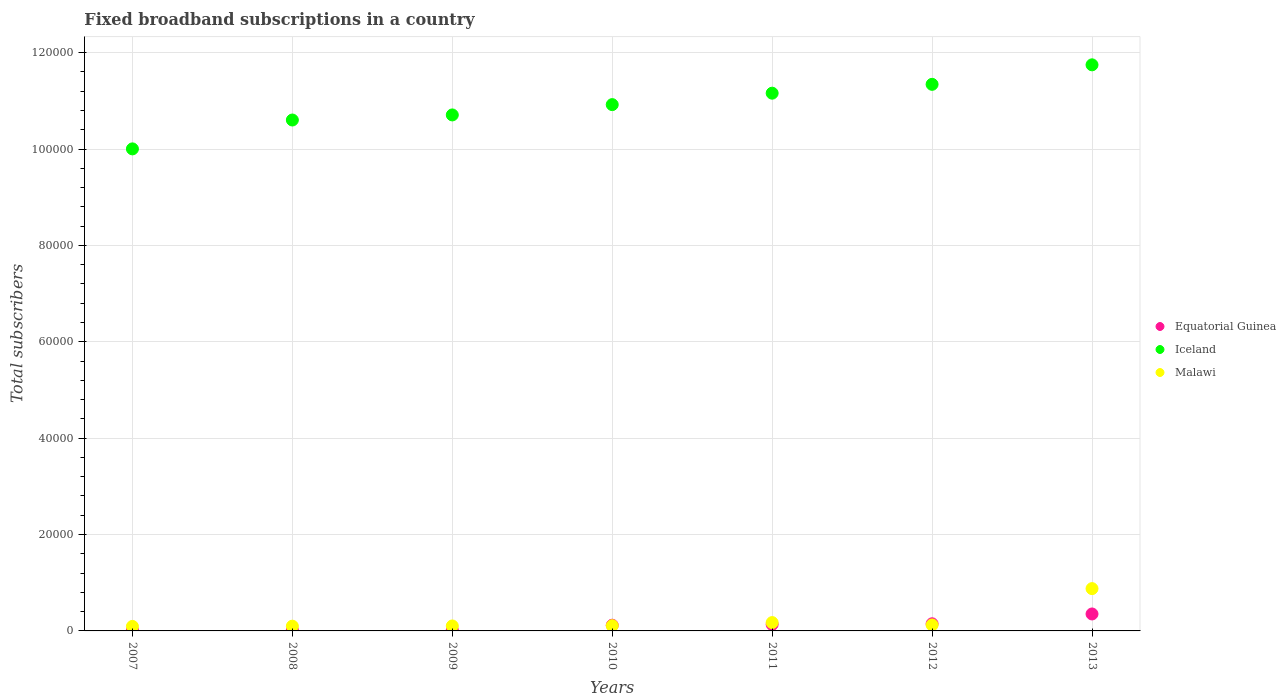What is the number of broadband subscriptions in Iceland in 2012?
Make the answer very short. 1.13e+05. Across all years, what is the maximum number of broadband subscriptions in Equatorial Guinea?
Your answer should be very brief. 3518. Across all years, what is the minimum number of broadband subscriptions in Iceland?
Offer a very short reply. 1.00e+05. What is the total number of broadband subscriptions in Iceland in the graph?
Make the answer very short. 7.65e+05. What is the difference between the number of broadband subscriptions in Iceland in 2007 and that in 2012?
Keep it short and to the point. -1.34e+04. What is the difference between the number of broadband subscriptions in Iceland in 2008 and the number of broadband subscriptions in Equatorial Guinea in 2007?
Keep it short and to the point. 1.06e+05. What is the average number of broadband subscriptions in Iceland per year?
Ensure brevity in your answer.  1.09e+05. In the year 2009, what is the difference between the number of broadband subscriptions in Malawi and number of broadband subscriptions in Equatorial Guinea?
Ensure brevity in your answer.  854. What is the ratio of the number of broadband subscriptions in Malawi in 2008 to that in 2010?
Make the answer very short. 0.91. Is the number of broadband subscriptions in Malawi in 2010 less than that in 2012?
Your answer should be very brief. Yes. What is the difference between the highest and the second highest number of broadband subscriptions in Malawi?
Provide a short and direct response. 7047. What is the difference between the highest and the lowest number of broadband subscriptions in Equatorial Guinea?
Make the answer very short. 3338. Is the sum of the number of broadband subscriptions in Equatorial Guinea in 2008 and 2010 greater than the maximum number of broadband subscriptions in Iceland across all years?
Make the answer very short. No. Is it the case that in every year, the sum of the number of broadband subscriptions in Iceland and number of broadband subscriptions in Malawi  is greater than the number of broadband subscriptions in Equatorial Guinea?
Make the answer very short. Yes. Is the number of broadband subscriptions in Equatorial Guinea strictly greater than the number of broadband subscriptions in Iceland over the years?
Offer a very short reply. No. How many dotlines are there?
Your answer should be compact. 3. How many years are there in the graph?
Your answer should be very brief. 7. Where does the legend appear in the graph?
Make the answer very short. Center right. How many legend labels are there?
Offer a very short reply. 3. How are the legend labels stacked?
Your answer should be very brief. Vertical. What is the title of the graph?
Provide a succinct answer. Fixed broadband subscriptions in a country. What is the label or title of the Y-axis?
Provide a short and direct response. Total subscribers. What is the Total subscribers of Equatorial Guinea in 2007?
Ensure brevity in your answer.  180. What is the Total subscribers in Iceland in 2007?
Provide a short and direct response. 1.00e+05. What is the Total subscribers in Malawi in 2007?
Make the answer very short. 934. What is the Total subscribers of Equatorial Guinea in 2008?
Give a very brief answer. 180. What is the Total subscribers in Iceland in 2008?
Your answer should be compact. 1.06e+05. What is the Total subscribers in Malawi in 2008?
Make the answer very short. 986. What is the Total subscribers in Equatorial Guinea in 2009?
Make the answer very short. 180. What is the Total subscribers of Iceland in 2009?
Keep it short and to the point. 1.07e+05. What is the Total subscribers in Malawi in 2009?
Give a very brief answer. 1034. What is the Total subscribers in Equatorial Guinea in 2010?
Offer a very short reply. 1186. What is the Total subscribers of Iceland in 2010?
Your answer should be very brief. 1.09e+05. What is the Total subscribers of Malawi in 2010?
Ensure brevity in your answer.  1085. What is the Total subscribers of Equatorial Guinea in 2011?
Your answer should be compact. 1346. What is the Total subscribers in Iceland in 2011?
Your answer should be compact. 1.12e+05. What is the Total subscribers in Malawi in 2011?
Your response must be concise. 1730. What is the Total subscribers in Equatorial Guinea in 2012?
Your answer should be compact. 1480. What is the Total subscribers of Iceland in 2012?
Provide a succinct answer. 1.13e+05. What is the Total subscribers in Malawi in 2012?
Provide a short and direct response. 1238. What is the Total subscribers of Equatorial Guinea in 2013?
Your answer should be compact. 3518. What is the Total subscribers of Iceland in 2013?
Ensure brevity in your answer.  1.17e+05. What is the Total subscribers in Malawi in 2013?
Provide a short and direct response. 8777. Across all years, what is the maximum Total subscribers of Equatorial Guinea?
Your answer should be compact. 3518. Across all years, what is the maximum Total subscribers in Iceland?
Offer a very short reply. 1.17e+05. Across all years, what is the maximum Total subscribers of Malawi?
Provide a succinct answer. 8777. Across all years, what is the minimum Total subscribers in Equatorial Guinea?
Keep it short and to the point. 180. Across all years, what is the minimum Total subscribers of Iceland?
Keep it short and to the point. 1.00e+05. Across all years, what is the minimum Total subscribers in Malawi?
Provide a short and direct response. 934. What is the total Total subscribers of Equatorial Guinea in the graph?
Make the answer very short. 8070. What is the total Total subscribers of Iceland in the graph?
Provide a short and direct response. 7.65e+05. What is the total Total subscribers in Malawi in the graph?
Your answer should be very brief. 1.58e+04. What is the difference between the Total subscribers of Equatorial Guinea in 2007 and that in 2008?
Make the answer very short. 0. What is the difference between the Total subscribers in Iceland in 2007 and that in 2008?
Provide a short and direct response. -5991. What is the difference between the Total subscribers in Malawi in 2007 and that in 2008?
Provide a short and direct response. -52. What is the difference between the Total subscribers in Iceland in 2007 and that in 2009?
Your answer should be very brief. -7046. What is the difference between the Total subscribers of Malawi in 2007 and that in 2009?
Ensure brevity in your answer.  -100. What is the difference between the Total subscribers of Equatorial Guinea in 2007 and that in 2010?
Your answer should be very brief. -1006. What is the difference between the Total subscribers of Iceland in 2007 and that in 2010?
Provide a succinct answer. -9186. What is the difference between the Total subscribers of Malawi in 2007 and that in 2010?
Offer a very short reply. -151. What is the difference between the Total subscribers in Equatorial Guinea in 2007 and that in 2011?
Make the answer very short. -1166. What is the difference between the Total subscribers in Iceland in 2007 and that in 2011?
Your response must be concise. -1.16e+04. What is the difference between the Total subscribers of Malawi in 2007 and that in 2011?
Make the answer very short. -796. What is the difference between the Total subscribers of Equatorial Guinea in 2007 and that in 2012?
Your answer should be compact. -1300. What is the difference between the Total subscribers of Iceland in 2007 and that in 2012?
Provide a short and direct response. -1.34e+04. What is the difference between the Total subscribers of Malawi in 2007 and that in 2012?
Offer a very short reply. -304. What is the difference between the Total subscribers of Equatorial Guinea in 2007 and that in 2013?
Keep it short and to the point. -3338. What is the difference between the Total subscribers of Iceland in 2007 and that in 2013?
Your answer should be very brief. -1.74e+04. What is the difference between the Total subscribers of Malawi in 2007 and that in 2013?
Offer a very short reply. -7843. What is the difference between the Total subscribers of Equatorial Guinea in 2008 and that in 2009?
Make the answer very short. 0. What is the difference between the Total subscribers in Iceland in 2008 and that in 2009?
Make the answer very short. -1055. What is the difference between the Total subscribers in Malawi in 2008 and that in 2009?
Provide a succinct answer. -48. What is the difference between the Total subscribers in Equatorial Guinea in 2008 and that in 2010?
Keep it short and to the point. -1006. What is the difference between the Total subscribers in Iceland in 2008 and that in 2010?
Offer a terse response. -3195. What is the difference between the Total subscribers in Malawi in 2008 and that in 2010?
Your answer should be very brief. -99. What is the difference between the Total subscribers in Equatorial Guinea in 2008 and that in 2011?
Keep it short and to the point. -1166. What is the difference between the Total subscribers of Iceland in 2008 and that in 2011?
Give a very brief answer. -5567. What is the difference between the Total subscribers of Malawi in 2008 and that in 2011?
Offer a terse response. -744. What is the difference between the Total subscribers of Equatorial Guinea in 2008 and that in 2012?
Your response must be concise. -1300. What is the difference between the Total subscribers in Iceland in 2008 and that in 2012?
Ensure brevity in your answer.  -7403. What is the difference between the Total subscribers of Malawi in 2008 and that in 2012?
Your answer should be compact. -252. What is the difference between the Total subscribers in Equatorial Guinea in 2008 and that in 2013?
Provide a short and direct response. -3338. What is the difference between the Total subscribers of Iceland in 2008 and that in 2013?
Your answer should be compact. -1.14e+04. What is the difference between the Total subscribers in Malawi in 2008 and that in 2013?
Your answer should be very brief. -7791. What is the difference between the Total subscribers of Equatorial Guinea in 2009 and that in 2010?
Offer a terse response. -1006. What is the difference between the Total subscribers in Iceland in 2009 and that in 2010?
Ensure brevity in your answer.  -2140. What is the difference between the Total subscribers of Malawi in 2009 and that in 2010?
Provide a short and direct response. -51. What is the difference between the Total subscribers of Equatorial Guinea in 2009 and that in 2011?
Your answer should be very brief. -1166. What is the difference between the Total subscribers of Iceland in 2009 and that in 2011?
Make the answer very short. -4512. What is the difference between the Total subscribers in Malawi in 2009 and that in 2011?
Provide a short and direct response. -696. What is the difference between the Total subscribers of Equatorial Guinea in 2009 and that in 2012?
Provide a succinct answer. -1300. What is the difference between the Total subscribers in Iceland in 2009 and that in 2012?
Give a very brief answer. -6348. What is the difference between the Total subscribers in Malawi in 2009 and that in 2012?
Offer a very short reply. -204. What is the difference between the Total subscribers in Equatorial Guinea in 2009 and that in 2013?
Make the answer very short. -3338. What is the difference between the Total subscribers of Iceland in 2009 and that in 2013?
Your answer should be very brief. -1.04e+04. What is the difference between the Total subscribers of Malawi in 2009 and that in 2013?
Offer a very short reply. -7743. What is the difference between the Total subscribers of Equatorial Guinea in 2010 and that in 2011?
Keep it short and to the point. -160. What is the difference between the Total subscribers in Iceland in 2010 and that in 2011?
Your answer should be compact. -2372. What is the difference between the Total subscribers in Malawi in 2010 and that in 2011?
Offer a terse response. -645. What is the difference between the Total subscribers of Equatorial Guinea in 2010 and that in 2012?
Ensure brevity in your answer.  -294. What is the difference between the Total subscribers of Iceland in 2010 and that in 2012?
Offer a very short reply. -4208. What is the difference between the Total subscribers in Malawi in 2010 and that in 2012?
Your response must be concise. -153. What is the difference between the Total subscribers in Equatorial Guinea in 2010 and that in 2013?
Your response must be concise. -2332. What is the difference between the Total subscribers of Iceland in 2010 and that in 2013?
Offer a very short reply. -8255. What is the difference between the Total subscribers of Malawi in 2010 and that in 2013?
Your answer should be compact. -7692. What is the difference between the Total subscribers in Equatorial Guinea in 2011 and that in 2012?
Your answer should be very brief. -134. What is the difference between the Total subscribers in Iceland in 2011 and that in 2012?
Keep it short and to the point. -1836. What is the difference between the Total subscribers in Malawi in 2011 and that in 2012?
Your response must be concise. 492. What is the difference between the Total subscribers of Equatorial Guinea in 2011 and that in 2013?
Make the answer very short. -2172. What is the difference between the Total subscribers in Iceland in 2011 and that in 2013?
Give a very brief answer. -5883. What is the difference between the Total subscribers in Malawi in 2011 and that in 2013?
Make the answer very short. -7047. What is the difference between the Total subscribers in Equatorial Guinea in 2012 and that in 2013?
Your answer should be compact. -2038. What is the difference between the Total subscribers of Iceland in 2012 and that in 2013?
Provide a succinct answer. -4047. What is the difference between the Total subscribers of Malawi in 2012 and that in 2013?
Your answer should be very brief. -7539. What is the difference between the Total subscribers in Equatorial Guinea in 2007 and the Total subscribers in Iceland in 2008?
Ensure brevity in your answer.  -1.06e+05. What is the difference between the Total subscribers in Equatorial Guinea in 2007 and the Total subscribers in Malawi in 2008?
Your response must be concise. -806. What is the difference between the Total subscribers of Iceland in 2007 and the Total subscribers of Malawi in 2008?
Your answer should be very brief. 9.90e+04. What is the difference between the Total subscribers in Equatorial Guinea in 2007 and the Total subscribers in Iceland in 2009?
Your answer should be compact. -1.07e+05. What is the difference between the Total subscribers in Equatorial Guinea in 2007 and the Total subscribers in Malawi in 2009?
Your answer should be very brief. -854. What is the difference between the Total subscribers in Iceland in 2007 and the Total subscribers in Malawi in 2009?
Provide a short and direct response. 9.90e+04. What is the difference between the Total subscribers in Equatorial Guinea in 2007 and the Total subscribers in Iceland in 2010?
Your response must be concise. -1.09e+05. What is the difference between the Total subscribers in Equatorial Guinea in 2007 and the Total subscribers in Malawi in 2010?
Give a very brief answer. -905. What is the difference between the Total subscribers in Iceland in 2007 and the Total subscribers in Malawi in 2010?
Provide a short and direct response. 9.89e+04. What is the difference between the Total subscribers in Equatorial Guinea in 2007 and the Total subscribers in Iceland in 2011?
Provide a succinct answer. -1.11e+05. What is the difference between the Total subscribers of Equatorial Guinea in 2007 and the Total subscribers of Malawi in 2011?
Ensure brevity in your answer.  -1550. What is the difference between the Total subscribers in Iceland in 2007 and the Total subscribers in Malawi in 2011?
Offer a very short reply. 9.83e+04. What is the difference between the Total subscribers of Equatorial Guinea in 2007 and the Total subscribers of Iceland in 2012?
Give a very brief answer. -1.13e+05. What is the difference between the Total subscribers of Equatorial Guinea in 2007 and the Total subscribers of Malawi in 2012?
Ensure brevity in your answer.  -1058. What is the difference between the Total subscribers in Iceland in 2007 and the Total subscribers in Malawi in 2012?
Provide a succinct answer. 9.88e+04. What is the difference between the Total subscribers in Equatorial Guinea in 2007 and the Total subscribers in Iceland in 2013?
Keep it short and to the point. -1.17e+05. What is the difference between the Total subscribers of Equatorial Guinea in 2007 and the Total subscribers of Malawi in 2013?
Your response must be concise. -8597. What is the difference between the Total subscribers of Iceland in 2007 and the Total subscribers of Malawi in 2013?
Offer a terse response. 9.12e+04. What is the difference between the Total subscribers of Equatorial Guinea in 2008 and the Total subscribers of Iceland in 2009?
Offer a terse response. -1.07e+05. What is the difference between the Total subscribers in Equatorial Guinea in 2008 and the Total subscribers in Malawi in 2009?
Provide a succinct answer. -854. What is the difference between the Total subscribers in Iceland in 2008 and the Total subscribers in Malawi in 2009?
Offer a terse response. 1.05e+05. What is the difference between the Total subscribers in Equatorial Guinea in 2008 and the Total subscribers in Iceland in 2010?
Offer a terse response. -1.09e+05. What is the difference between the Total subscribers in Equatorial Guinea in 2008 and the Total subscribers in Malawi in 2010?
Offer a terse response. -905. What is the difference between the Total subscribers in Iceland in 2008 and the Total subscribers in Malawi in 2010?
Your response must be concise. 1.05e+05. What is the difference between the Total subscribers in Equatorial Guinea in 2008 and the Total subscribers in Iceland in 2011?
Offer a terse response. -1.11e+05. What is the difference between the Total subscribers of Equatorial Guinea in 2008 and the Total subscribers of Malawi in 2011?
Provide a succinct answer. -1550. What is the difference between the Total subscribers in Iceland in 2008 and the Total subscribers in Malawi in 2011?
Ensure brevity in your answer.  1.04e+05. What is the difference between the Total subscribers in Equatorial Guinea in 2008 and the Total subscribers in Iceland in 2012?
Give a very brief answer. -1.13e+05. What is the difference between the Total subscribers of Equatorial Guinea in 2008 and the Total subscribers of Malawi in 2012?
Provide a short and direct response. -1058. What is the difference between the Total subscribers in Iceland in 2008 and the Total subscribers in Malawi in 2012?
Give a very brief answer. 1.05e+05. What is the difference between the Total subscribers in Equatorial Guinea in 2008 and the Total subscribers in Iceland in 2013?
Your response must be concise. -1.17e+05. What is the difference between the Total subscribers in Equatorial Guinea in 2008 and the Total subscribers in Malawi in 2013?
Your answer should be very brief. -8597. What is the difference between the Total subscribers in Iceland in 2008 and the Total subscribers in Malawi in 2013?
Give a very brief answer. 9.72e+04. What is the difference between the Total subscribers in Equatorial Guinea in 2009 and the Total subscribers in Iceland in 2010?
Give a very brief answer. -1.09e+05. What is the difference between the Total subscribers of Equatorial Guinea in 2009 and the Total subscribers of Malawi in 2010?
Keep it short and to the point. -905. What is the difference between the Total subscribers of Iceland in 2009 and the Total subscribers of Malawi in 2010?
Make the answer very short. 1.06e+05. What is the difference between the Total subscribers of Equatorial Guinea in 2009 and the Total subscribers of Iceland in 2011?
Give a very brief answer. -1.11e+05. What is the difference between the Total subscribers in Equatorial Guinea in 2009 and the Total subscribers in Malawi in 2011?
Offer a very short reply. -1550. What is the difference between the Total subscribers in Iceland in 2009 and the Total subscribers in Malawi in 2011?
Give a very brief answer. 1.05e+05. What is the difference between the Total subscribers in Equatorial Guinea in 2009 and the Total subscribers in Iceland in 2012?
Keep it short and to the point. -1.13e+05. What is the difference between the Total subscribers in Equatorial Guinea in 2009 and the Total subscribers in Malawi in 2012?
Give a very brief answer. -1058. What is the difference between the Total subscribers in Iceland in 2009 and the Total subscribers in Malawi in 2012?
Offer a terse response. 1.06e+05. What is the difference between the Total subscribers of Equatorial Guinea in 2009 and the Total subscribers of Iceland in 2013?
Your response must be concise. -1.17e+05. What is the difference between the Total subscribers in Equatorial Guinea in 2009 and the Total subscribers in Malawi in 2013?
Your response must be concise. -8597. What is the difference between the Total subscribers in Iceland in 2009 and the Total subscribers in Malawi in 2013?
Provide a short and direct response. 9.83e+04. What is the difference between the Total subscribers of Equatorial Guinea in 2010 and the Total subscribers of Iceland in 2011?
Provide a succinct answer. -1.10e+05. What is the difference between the Total subscribers of Equatorial Guinea in 2010 and the Total subscribers of Malawi in 2011?
Ensure brevity in your answer.  -544. What is the difference between the Total subscribers of Iceland in 2010 and the Total subscribers of Malawi in 2011?
Offer a terse response. 1.07e+05. What is the difference between the Total subscribers in Equatorial Guinea in 2010 and the Total subscribers in Iceland in 2012?
Your answer should be compact. -1.12e+05. What is the difference between the Total subscribers of Equatorial Guinea in 2010 and the Total subscribers of Malawi in 2012?
Offer a very short reply. -52. What is the difference between the Total subscribers of Iceland in 2010 and the Total subscribers of Malawi in 2012?
Offer a very short reply. 1.08e+05. What is the difference between the Total subscribers in Equatorial Guinea in 2010 and the Total subscribers in Iceland in 2013?
Your response must be concise. -1.16e+05. What is the difference between the Total subscribers of Equatorial Guinea in 2010 and the Total subscribers of Malawi in 2013?
Your answer should be compact. -7591. What is the difference between the Total subscribers in Iceland in 2010 and the Total subscribers in Malawi in 2013?
Provide a short and direct response. 1.00e+05. What is the difference between the Total subscribers of Equatorial Guinea in 2011 and the Total subscribers of Iceland in 2012?
Offer a terse response. -1.12e+05. What is the difference between the Total subscribers in Equatorial Guinea in 2011 and the Total subscribers in Malawi in 2012?
Provide a succinct answer. 108. What is the difference between the Total subscribers in Iceland in 2011 and the Total subscribers in Malawi in 2012?
Provide a short and direct response. 1.10e+05. What is the difference between the Total subscribers in Equatorial Guinea in 2011 and the Total subscribers in Iceland in 2013?
Provide a succinct answer. -1.16e+05. What is the difference between the Total subscribers in Equatorial Guinea in 2011 and the Total subscribers in Malawi in 2013?
Keep it short and to the point. -7431. What is the difference between the Total subscribers of Iceland in 2011 and the Total subscribers of Malawi in 2013?
Your response must be concise. 1.03e+05. What is the difference between the Total subscribers in Equatorial Guinea in 2012 and the Total subscribers in Iceland in 2013?
Your answer should be compact. -1.16e+05. What is the difference between the Total subscribers in Equatorial Guinea in 2012 and the Total subscribers in Malawi in 2013?
Your answer should be compact. -7297. What is the difference between the Total subscribers of Iceland in 2012 and the Total subscribers of Malawi in 2013?
Give a very brief answer. 1.05e+05. What is the average Total subscribers of Equatorial Guinea per year?
Offer a terse response. 1152.86. What is the average Total subscribers in Iceland per year?
Your response must be concise. 1.09e+05. What is the average Total subscribers of Malawi per year?
Keep it short and to the point. 2254.86. In the year 2007, what is the difference between the Total subscribers of Equatorial Guinea and Total subscribers of Iceland?
Ensure brevity in your answer.  -9.98e+04. In the year 2007, what is the difference between the Total subscribers in Equatorial Guinea and Total subscribers in Malawi?
Offer a very short reply. -754. In the year 2007, what is the difference between the Total subscribers of Iceland and Total subscribers of Malawi?
Your response must be concise. 9.91e+04. In the year 2008, what is the difference between the Total subscribers of Equatorial Guinea and Total subscribers of Iceland?
Your answer should be compact. -1.06e+05. In the year 2008, what is the difference between the Total subscribers in Equatorial Guinea and Total subscribers in Malawi?
Offer a terse response. -806. In the year 2008, what is the difference between the Total subscribers of Iceland and Total subscribers of Malawi?
Offer a very short reply. 1.05e+05. In the year 2009, what is the difference between the Total subscribers of Equatorial Guinea and Total subscribers of Iceland?
Offer a very short reply. -1.07e+05. In the year 2009, what is the difference between the Total subscribers of Equatorial Guinea and Total subscribers of Malawi?
Offer a terse response. -854. In the year 2009, what is the difference between the Total subscribers in Iceland and Total subscribers in Malawi?
Your answer should be very brief. 1.06e+05. In the year 2010, what is the difference between the Total subscribers in Equatorial Guinea and Total subscribers in Iceland?
Your answer should be compact. -1.08e+05. In the year 2010, what is the difference between the Total subscribers in Equatorial Guinea and Total subscribers in Malawi?
Give a very brief answer. 101. In the year 2010, what is the difference between the Total subscribers of Iceland and Total subscribers of Malawi?
Your answer should be very brief. 1.08e+05. In the year 2011, what is the difference between the Total subscribers of Equatorial Guinea and Total subscribers of Iceland?
Make the answer very short. -1.10e+05. In the year 2011, what is the difference between the Total subscribers in Equatorial Guinea and Total subscribers in Malawi?
Give a very brief answer. -384. In the year 2011, what is the difference between the Total subscribers in Iceland and Total subscribers in Malawi?
Ensure brevity in your answer.  1.10e+05. In the year 2012, what is the difference between the Total subscribers in Equatorial Guinea and Total subscribers in Iceland?
Your response must be concise. -1.12e+05. In the year 2012, what is the difference between the Total subscribers in Equatorial Guinea and Total subscribers in Malawi?
Give a very brief answer. 242. In the year 2012, what is the difference between the Total subscribers of Iceland and Total subscribers of Malawi?
Ensure brevity in your answer.  1.12e+05. In the year 2013, what is the difference between the Total subscribers of Equatorial Guinea and Total subscribers of Iceland?
Your answer should be compact. -1.14e+05. In the year 2013, what is the difference between the Total subscribers of Equatorial Guinea and Total subscribers of Malawi?
Provide a succinct answer. -5259. In the year 2013, what is the difference between the Total subscribers of Iceland and Total subscribers of Malawi?
Give a very brief answer. 1.09e+05. What is the ratio of the Total subscribers in Iceland in 2007 to that in 2008?
Your answer should be very brief. 0.94. What is the ratio of the Total subscribers in Malawi in 2007 to that in 2008?
Your response must be concise. 0.95. What is the ratio of the Total subscribers in Iceland in 2007 to that in 2009?
Offer a very short reply. 0.93. What is the ratio of the Total subscribers in Malawi in 2007 to that in 2009?
Ensure brevity in your answer.  0.9. What is the ratio of the Total subscribers in Equatorial Guinea in 2007 to that in 2010?
Provide a succinct answer. 0.15. What is the ratio of the Total subscribers of Iceland in 2007 to that in 2010?
Offer a terse response. 0.92. What is the ratio of the Total subscribers in Malawi in 2007 to that in 2010?
Your response must be concise. 0.86. What is the ratio of the Total subscribers in Equatorial Guinea in 2007 to that in 2011?
Make the answer very short. 0.13. What is the ratio of the Total subscribers in Iceland in 2007 to that in 2011?
Your answer should be very brief. 0.9. What is the ratio of the Total subscribers in Malawi in 2007 to that in 2011?
Provide a short and direct response. 0.54. What is the ratio of the Total subscribers of Equatorial Guinea in 2007 to that in 2012?
Keep it short and to the point. 0.12. What is the ratio of the Total subscribers of Iceland in 2007 to that in 2012?
Provide a succinct answer. 0.88. What is the ratio of the Total subscribers in Malawi in 2007 to that in 2012?
Make the answer very short. 0.75. What is the ratio of the Total subscribers of Equatorial Guinea in 2007 to that in 2013?
Your answer should be very brief. 0.05. What is the ratio of the Total subscribers of Iceland in 2007 to that in 2013?
Your answer should be compact. 0.85. What is the ratio of the Total subscribers of Malawi in 2007 to that in 2013?
Ensure brevity in your answer.  0.11. What is the ratio of the Total subscribers of Equatorial Guinea in 2008 to that in 2009?
Ensure brevity in your answer.  1. What is the ratio of the Total subscribers of Malawi in 2008 to that in 2009?
Keep it short and to the point. 0.95. What is the ratio of the Total subscribers in Equatorial Guinea in 2008 to that in 2010?
Your answer should be compact. 0.15. What is the ratio of the Total subscribers of Iceland in 2008 to that in 2010?
Provide a succinct answer. 0.97. What is the ratio of the Total subscribers of Malawi in 2008 to that in 2010?
Ensure brevity in your answer.  0.91. What is the ratio of the Total subscribers in Equatorial Guinea in 2008 to that in 2011?
Offer a terse response. 0.13. What is the ratio of the Total subscribers in Iceland in 2008 to that in 2011?
Give a very brief answer. 0.95. What is the ratio of the Total subscribers of Malawi in 2008 to that in 2011?
Offer a terse response. 0.57. What is the ratio of the Total subscribers of Equatorial Guinea in 2008 to that in 2012?
Provide a short and direct response. 0.12. What is the ratio of the Total subscribers in Iceland in 2008 to that in 2012?
Offer a terse response. 0.93. What is the ratio of the Total subscribers of Malawi in 2008 to that in 2012?
Provide a succinct answer. 0.8. What is the ratio of the Total subscribers in Equatorial Guinea in 2008 to that in 2013?
Provide a succinct answer. 0.05. What is the ratio of the Total subscribers in Iceland in 2008 to that in 2013?
Ensure brevity in your answer.  0.9. What is the ratio of the Total subscribers in Malawi in 2008 to that in 2013?
Provide a short and direct response. 0.11. What is the ratio of the Total subscribers of Equatorial Guinea in 2009 to that in 2010?
Keep it short and to the point. 0.15. What is the ratio of the Total subscribers of Iceland in 2009 to that in 2010?
Ensure brevity in your answer.  0.98. What is the ratio of the Total subscribers in Malawi in 2009 to that in 2010?
Keep it short and to the point. 0.95. What is the ratio of the Total subscribers of Equatorial Guinea in 2009 to that in 2011?
Ensure brevity in your answer.  0.13. What is the ratio of the Total subscribers in Iceland in 2009 to that in 2011?
Your answer should be very brief. 0.96. What is the ratio of the Total subscribers in Malawi in 2009 to that in 2011?
Your response must be concise. 0.6. What is the ratio of the Total subscribers of Equatorial Guinea in 2009 to that in 2012?
Offer a very short reply. 0.12. What is the ratio of the Total subscribers of Iceland in 2009 to that in 2012?
Offer a very short reply. 0.94. What is the ratio of the Total subscribers of Malawi in 2009 to that in 2012?
Your response must be concise. 0.84. What is the ratio of the Total subscribers in Equatorial Guinea in 2009 to that in 2013?
Ensure brevity in your answer.  0.05. What is the ratio of the Total subscribers of Iceland in 2009 to that in 2013?
Give a very brief answer. 0.91. What is the ratio of the Total subscribers in Malawi in 2009 to that in 2013?
Offer a very short reply. 0.12. What is the ratio of the Total subscribers of Equatorial Guinea in 2010 to that in 2011?
Your response must be concise. 0.88. What is the ratio of the Total subscribers of Iceland in 2010 to that in 2011?
Make the answer very short. 0.98. What is the ratio of the Total subscribers in Malawi in 2010 to that in 2011?
Offer a very short reply. 0.63. What is the ratio of the Total subscribers of Equatorial Guinea in 2010 to that in 2012?
Offer a very short reply. 0.8. What is the ratio of the Total subscribers in Iceland in 2010 to that in 2012?
Your response must be concise. 0.96. What is the ratio of the Total subscribers of Malawi in 2010 to that in 2012?
Your answer should be compact. 0.88. What is the ratio of the Total subscribers of Equatorial Guinea in 2010 to that in 2013?
Provide a succinct answer. 0.34. What is the ratio of the Total subscribers of Iceland in 2010 to that in 2013?
Offer a very short reply. 0.93. What is the ratio of the Total subscribers of Malawi in 2010 to that in 2013?
Ensure brevity in your answer.  0.12. What is the ratio of the Total subscribers in Equatorial Guinea in 2011 to that in 2012?
Provide a succinct answer. 0.91. What is the ratio of the Total subscribers in Iceland in 2011 to that in 2012?
Give a very brief answer. 0.98. What is the ratio of the Total subscribers in Malawi in 2011 to that in 2012?
Provide a succinct answer. 1.4. What is the ratio of the Total subscribers of Equatorial Guinea in 2011 to that in 2013?
Offer a terse response. 0.38. What is the ratio of the Total subscribers of Iceland in 2011 to that in 2013?
Your response must be concise. 0.95. What is the ratio of the Total subscribers of Malawi in 2011 to that in 2013?
Ensure brevity in your answer.  0.2. What is the ratio of the Total subscribers in Equatorial Guinea in 2012 to that in 2013?
Give a very brief answer. 0.42. What is the ratio of the Total subscribers in Iceland in 2012 to that in 2013?
Your response must be concise. 0.97. What is the ratio of the Total subscribers of Malawi in 2012 to that in 2013?
Provide a short and direct response. 0.14. What is the difference between the highest and the second highest Total subscribers in Equatorial Guinea?
Provide a succinct answer. 2038. What is the difference between the highest and the second highest Total subscribers in Iceland?
Ensure brevity in your answer.  4047. What is the difference between the highest and the second highest Total subscribers in Malawi?
Your response must be concise. 7047. What is the difference between the highest and the lowest Total subscribers in Equatorial Guinea?
Give a very brief answer. 3338. What is the difference between the highest and the lowest Total subscribers in Iceland?
Give a very brief answer. 1.74e+04. What is the difference between the highest and the lowest Total subscribers in Malawi?
Make the answer very short. 7843. 